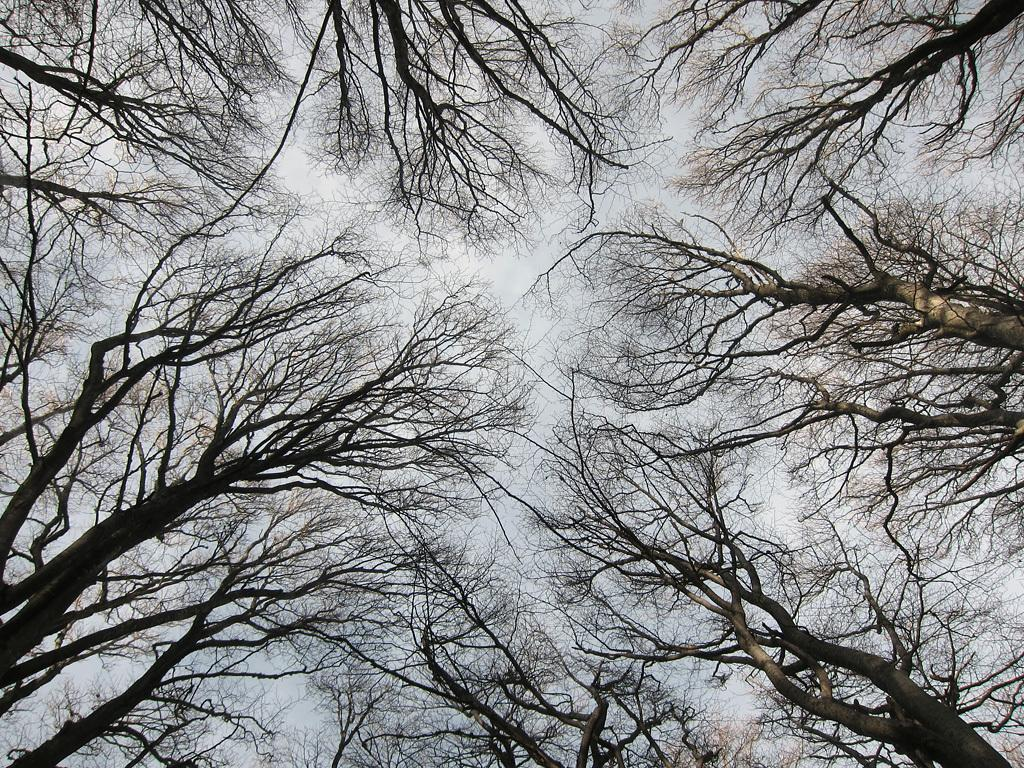What type of vegetation is present in the image? The image contains trees. What can be seen in the background of the image? The sky is visible in the background of the image. How many pigs are visible in the image? There are no pigs present in the image. What is the mother doing in the image? There is no mother or any human figure present in the image. 